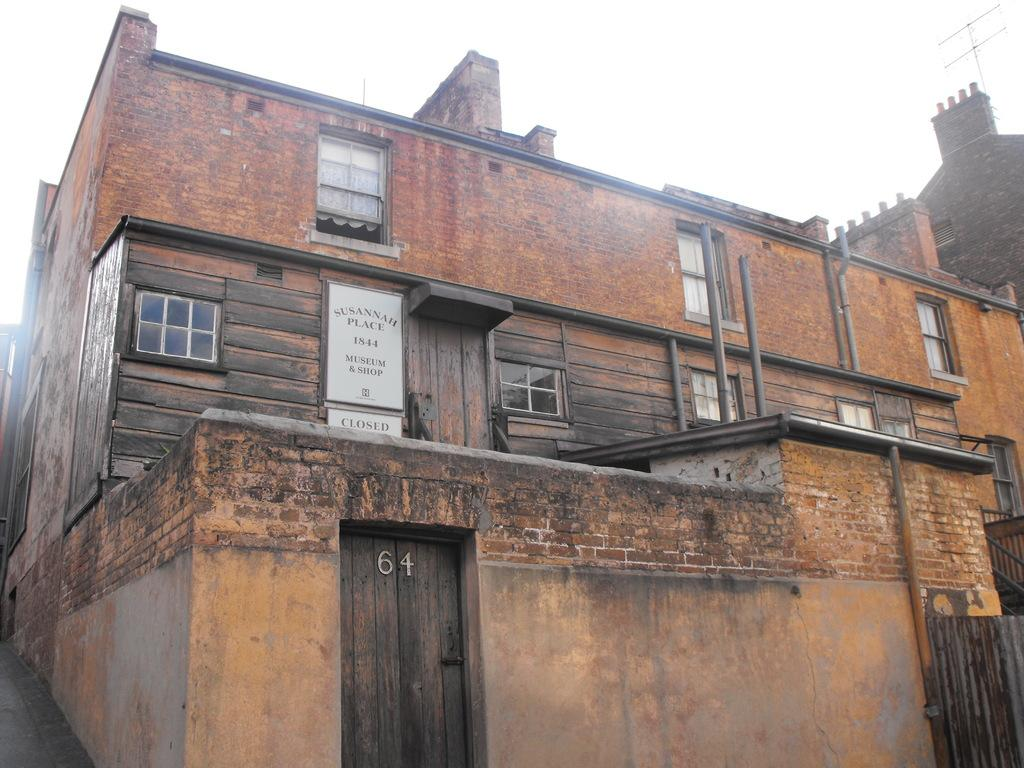What type of structure is in the image? There is a building in the image. What features can be seen on the building? The building has windows and a door. What additional object is present in the image? There is a text board in the image. What can be seen in the background of the image? The sky is visible in the image. What is located on the right side of the image? There is an antenna on the right side of the image. How many crates are stacked next to the building in the image? There are no crates present in the image. Is there anyone sleeping on the text board in the image? There is no one sleeping on the text board in the image. 